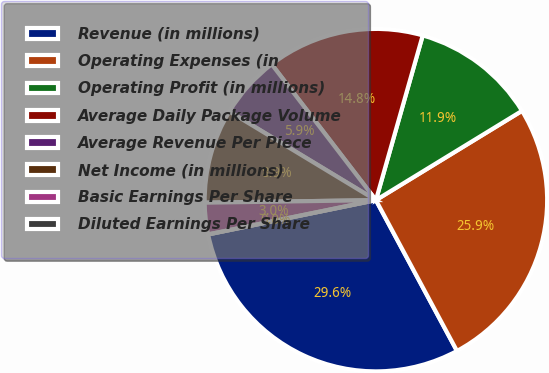<chart> <loc_0><loc_0><loc_500><loc_500><pie_chart><fcel>Revenue (in millions)<fcel>Operating Expenses (in<fcel>Operating Profit (in millions)<fcel>Average Daily Package Volume<fcel>Average Revenue Per Piece<fcel>Net Income (in millions)<fcel>Basic Earnings Per Share<fcel>Diluted Earnings Per Share<nl><fcel>29.64%<fcel>25.88%<fcel>11.86%<fcel>14.82%<fcel>5.93%<fcel>8.89%<fcel>2.97%<fcel>0.0%<nl></chart> 